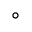Convert formula to latex. <formula><loc_0><loc_0><loc_500><loc_500>^ { \circ }</formula> 